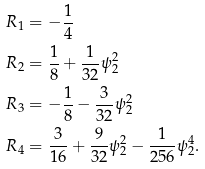<formula> <loc_0><loc_0><loc_500><loc_500>R _ { 1 } & = - \frac { 1 } { 4 } \\ R _ { 2 } & = \frac { 1 } { 8 } + \frac { 1 } { 3 2 } \psi _ { 2 } ^ { 2 } \\ R _ { 3 } & = - \frac { 1 } { 8 } - \frac { 3 } { 3 2 } \psi _ { 2 } ^ { 2 } \\ R _ { 4 } & = \frac { 3 } { 1 6 } + \frac { 9 } { 3 2 } \psi _ { 2 } ^ { 2 } - \frac { 1 } { 2 5 6 } \psi _ { 2 } ^ { 4 } .</formula> 